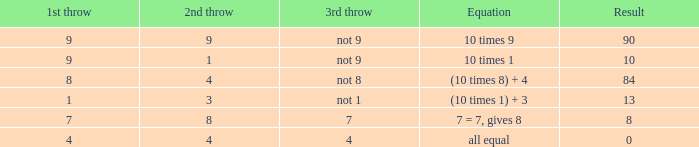When the 3rd throw isn't 8, what is the consequence? 84.0. 